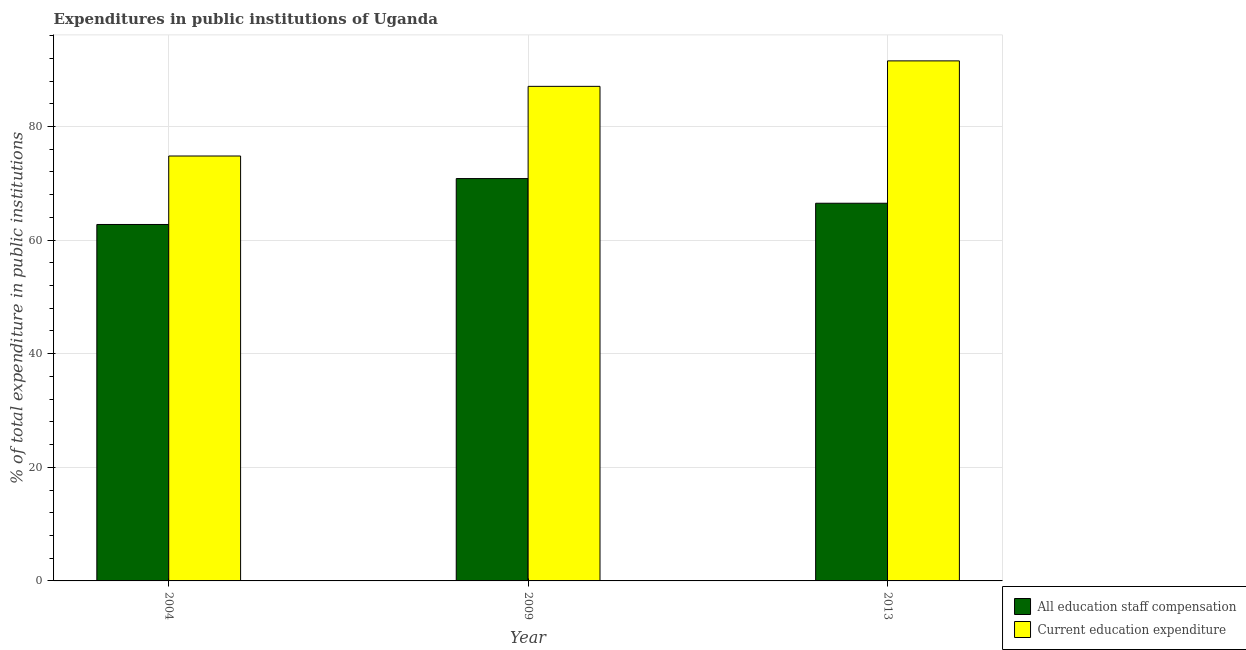How many groups of bars are there?
Provide a succinct answer. 3. Are the number of bars per tick equal to the number of legend labels?
Ensure brevity in your answer.  Yes. How many bars are there on the 1st tick from the right?
Offer a terse response. 2. In how many cases, is the number of bars for a given year not equal to the number of legend labels?
Make the answer very short. 0. What is the expenditure in education in 2004?
Ensure brevity in your answer.  74.8. Across all years, what is the maximum expenditure in education?
Give a very brief answer. 91.54. Across all years, what is the minimum expenditure in staff compensation?
Offer a terse response. 62.74. In which year was the expenditure in staff compensation maximum?
Your response must be concise. 2009. In which year was the expenditure in education minimum?
Your answer should be compact. 2004. What is the total expenditure in education in the graph?
Provide a succinct answer. 253.4. What is the difference between the expenditure in education in 2009 and that in 2013?
Offer a terse response. -4.49. What is the difference between the expenditure in staff compensation in 2013 and the expenditure in education in 2004?
Make the answer very short. 3.74. What is the average expenditure in education per year?
Your answer should be compact. 84.47. In how many years, is the expenditure in education greater than 16 %?
Give a very brief answer. 3. What is the ratio of the expenditure in education in 2004 to that in 2009?
Offer a terse response. 0.86. What is the difference between the highest and the second highest expenditure in staff compensation?
Your response must be concise. 4.34. What is the difference between the highest and the lowest expenditure in education?
Offer a terse response. 16.75. What does the 1st bar from the left in 2009 represents?
Make the answer very short. All education staff compensation. What does the 1st bar from the right in 2009 represents?
Provide a succinct answer. Current education expenditure. How many bars are there?
Give a very brief answer. 6. Are all the bars in the graph horizontal?
Your response must be concise. No. How many years are there in the graph?
Your answer should be compact. 3. What is the difference between two consecutive major ticks on the Y-axis?
Ensure brevity in your answer.  20. Does the graph contain any zero values?
Your answer should be very brief. No. Where does the legend appear in the graph?
Provide a succinct answer. Bottom right. How are the legend labels stacked?
Keep it short and to the point. Vertical. What is the title of the graph?
Keep it short and to the point. Expenditures in public institutions of Uganda. What is the label or title of the X-axis?
Your answer should be very brief. Year. What is the label or title of the Y-axis?
Your answer should be compact. % of total expenditure in public institutions. What is the % of total expenditure in public institutions of All education staff compensation in 2004?
Your answer should be very brief. 62.74. What is the % of total expenditure in public institutions of Current education expenditure in 2004?
Provide a succinct answer. 74.8. What is the % of total expenditure in public institutions of All education staff compensation in 2009?
Provide a succinct answer. 70.83. What is the % of total expenditure in public institutions of Current education expenditure in 2009?
Your answer should be compact. 87.06. What is the % of total expenditure in public institutions in All education staff compensation in 2013?
Your answer should be compact. 66.48. What is the % of total expenditure in public institutions in Current education expenditure in 2013?
Offer a very short reply. 91.54. Across all years, what is the maximum % of total expenditure in public institutions of All education staff compensation?
Make the answer very short. 70.83. Across all years, what is the maximum % of total expenditure in public institutions in Current education expenditure?
Your answer should be compact. 91.54. Across all years, what is the minimum % of total expenditure in public institutions of All education staff compensation?
Offer a terse response. 62.74. Across all years, what is the minimum % of total expenditure in public institutions of Current education expenditure?
Give a very brief answer. 74.8. What is the total % of total expenditure in public institutions of All education staff compensation in the graph?
Offer a very short reply. 200.05. What is the total % of total expenditure in public institutions of Current education expenditure in the graph?
Your response must be concise. 253.4. What is the difference between the % of total expenditure in public institutions of All education staff compensation in 2004 and that in 2009?
Provide a succinct answer. -8.08. What is the difference between the % of total expenditure in public institutions of Current education expenditure in 2004 and that in 2009?
Your response must be concise. -12.26. What is the difference between the % of total expenditure in public institutions in All education staff compensation in 2004 and that in 2013?
Your answer should be compact. -3.74. What is the difference between the % of total expenditure in public institutions in Current education expenditure in 2004 and that in 2013?
Your answer should be very brief. -16.75. What is the difference between the % of total expenditure in public institutions in All education staff compensation in 2009 and that in 2013?
Offer a very short reply. 4.34. What is the difference between the % of total expenditure in public institutions in Current education expenditure in 2009 and that in 2013?
Offer a very short reply. -4.49. What is the difference between the % of total expenditure in public institutions of All education staff compensation in 2004 and the % of total expenditure in public institutions of Current education expenditure in 2009?
Keep it short and to the point. -24.31. What is the difference between the % of total expenditure in public institutions in All education staff compensation in 2004 and the % of total expenditure in public institutions in Current education expenditure in 2013?
Make the answer very short. -28.8. What is the difference between the % of total expenditure in public institutions of All education staff compensation in 2009 and the % of total expenditure in public institutions of Current education expenditure in 2013?
Provide a succinct answer. -20.72. What is the average % of total expenditure in public institutions of All education staff compensation per year?
Your answer should be very brief. 66.68. What is the average % of total expenditure in public institutions of Current education expenditure per year?
Give a very brief answer. 84.47. In the year 2004, what is the difference between the % of total expenditure in public institutions of All education staff compensation and % of total expenditure in public institutions of Current education expenditure?
Provide a succinct answer. -12.05. In the year 2009, what is the difference between the % of total expenditure in public institutions of All education staff compensation and % of total expenditure in public institutions of Current education expenditure?
Provide a succinct answer. -16.23. In the year 2013, what is the difference between the % of total expenditure in public institutions of All education staff compensation and % of total expenditure in public institutions of Current education expenditure?
Keep it short and to the point. -25.06. What is the ratio of the % of total expenditure in public institutions in All education staff compensation in 2004 to that in 2009?
Your answer should be very brief. 0.89. What is the ratio of the % of total expenditure in public institutions of Current education expenditure in 2004 to that in 2009?
Provide a short and direct response. 0.86. What is the ratio of the % of total expenditure in public institutions in All education staff compensation in 2004 to that in 2013?
Make the answer very short. 0.94. What is the ratio of the % of total expenditure in public institutions in Current education expenditure in 2004 to that in 2013?
Offer a very short reply. 0.82. What is the ratio of the % of total expenditure in public institutions in All education staff compensation in 2009 to that in 2013?
Offer a very short reply. 1.07. What is the ratio of the % of total expenditure in public institutions of Current education expenditure in 2009 to that in 2013?
Keep it short and to the point. 0.95. What is the difference between the highest and the second highest % of total expenditure in public institutions of All education staff compensation?
Offer a very short reply. 4.34. What is the difference between the highest and the second highest % of total expenditure in public institutions of Current education expenditure?
Provide a succinct answer. 4.49. What is the difference between the highest and the lowest % of total expenditure in public institutions of All education staff compensation?
Make the answer very short. 8.08. What is the difference between the highest and the lowest % of total expenditure in public institutions in Current education expenditure?
Make the answer very short. 16.75. 